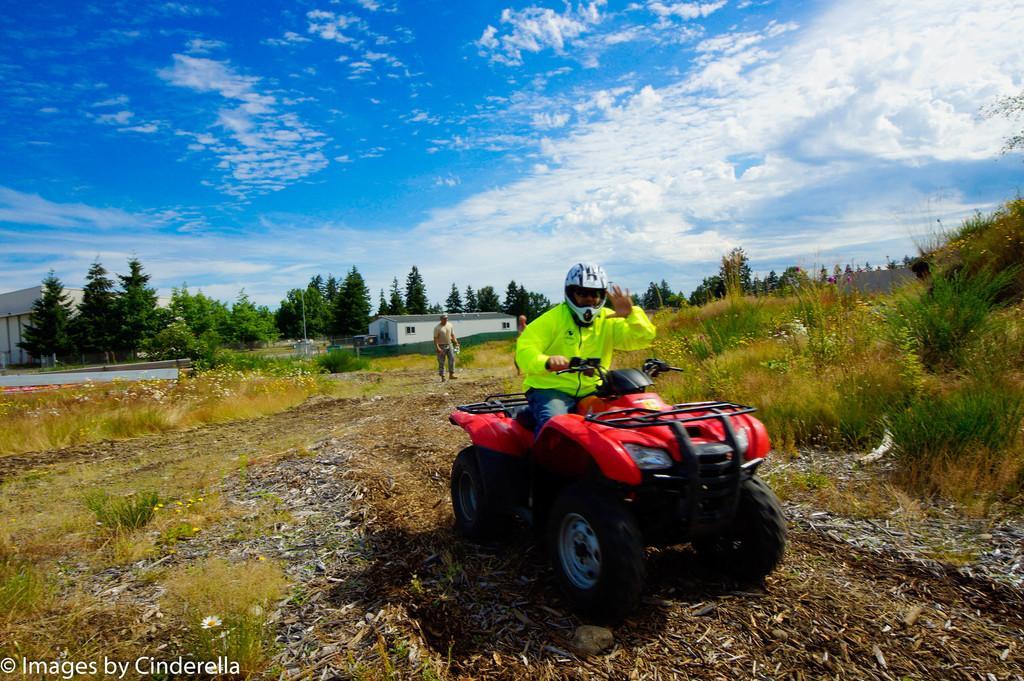Please provide a concise description of this image. In this image I can see a man is sitting on a vehicle and wearing a helmet. In the background I can see buildings, trees, the grass and the sky. 